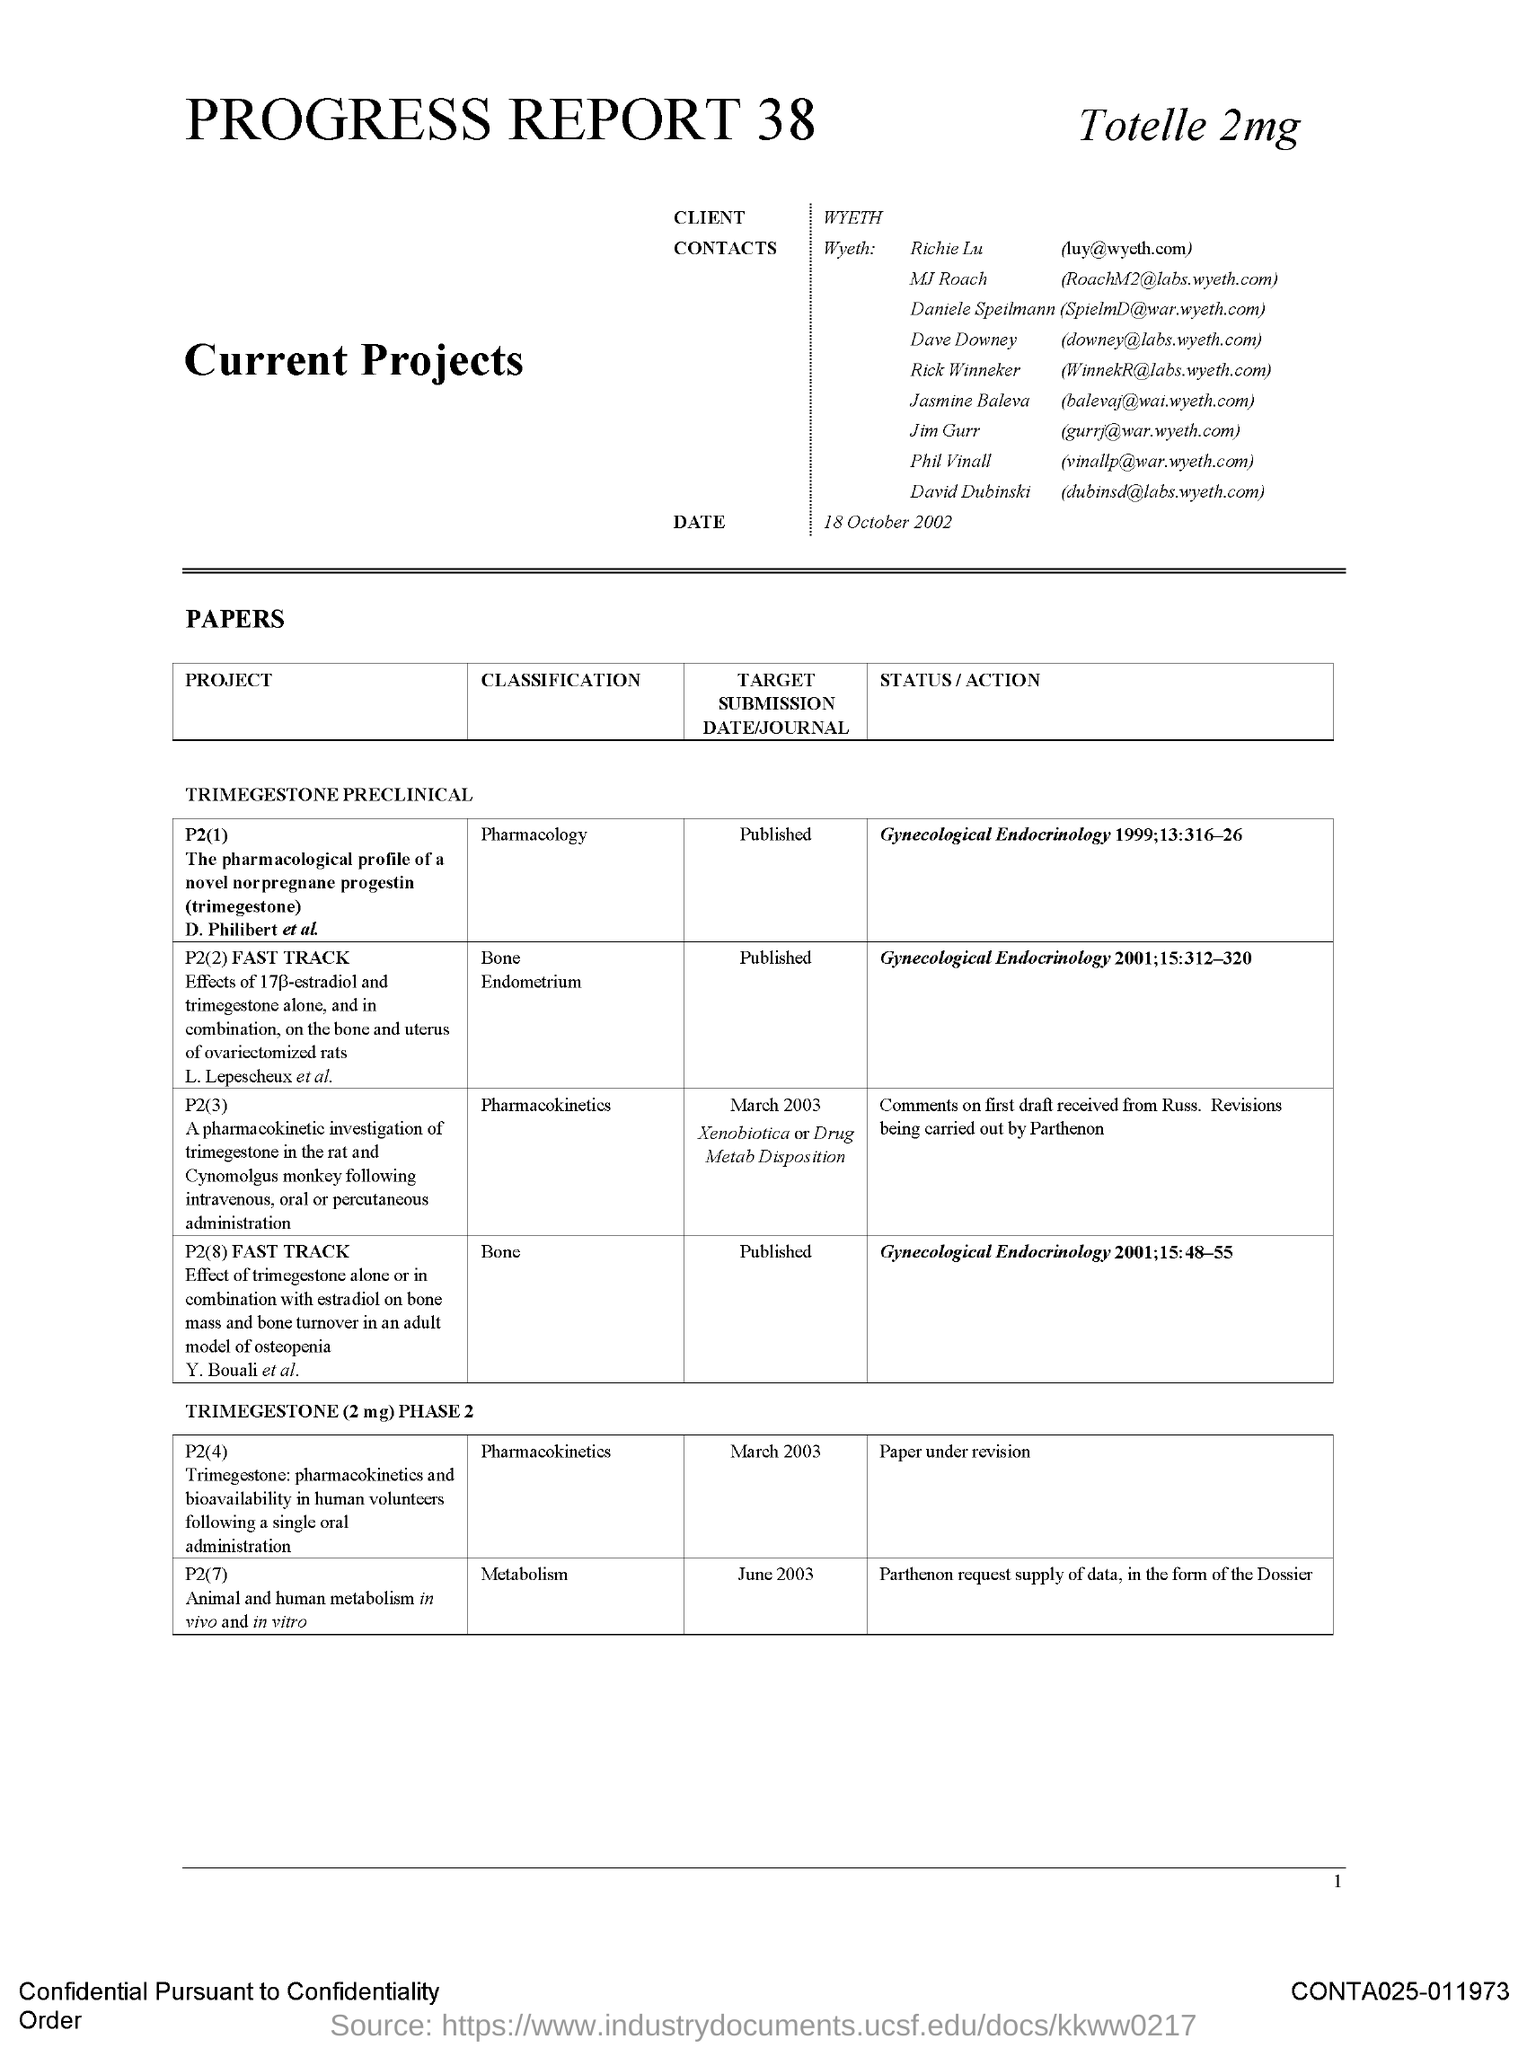What is classification of project P2(2)?
Provide a succinct answer. Bone Endometrium. 